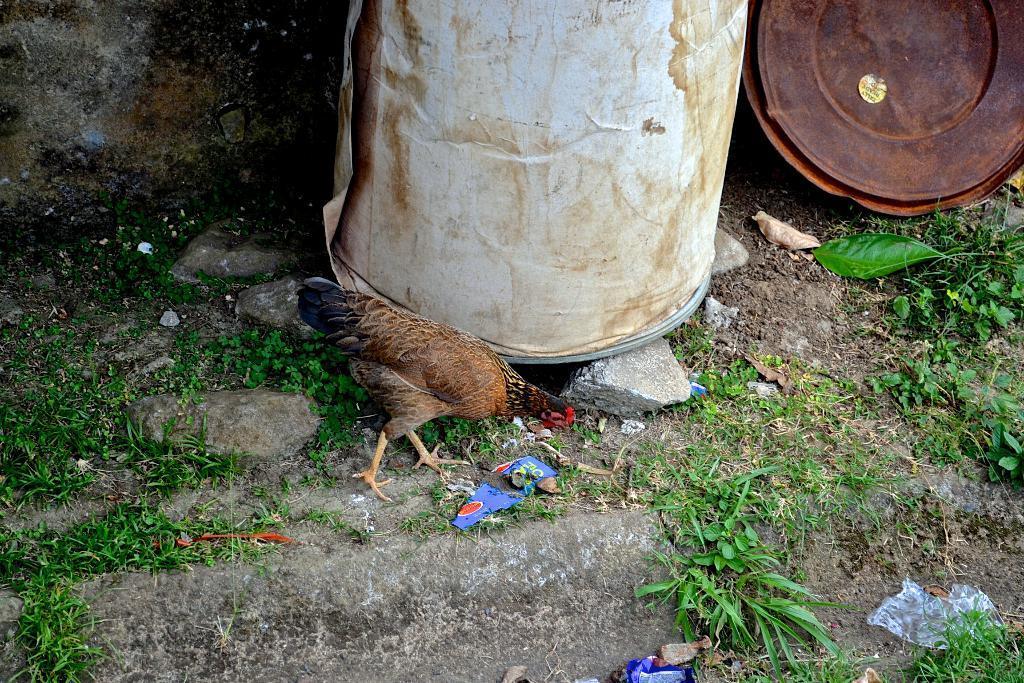Could you give a brief overview of what you see in this image? There is a hen. Near to the hen there are barrels. On the ground there are covers, plants and stones. 